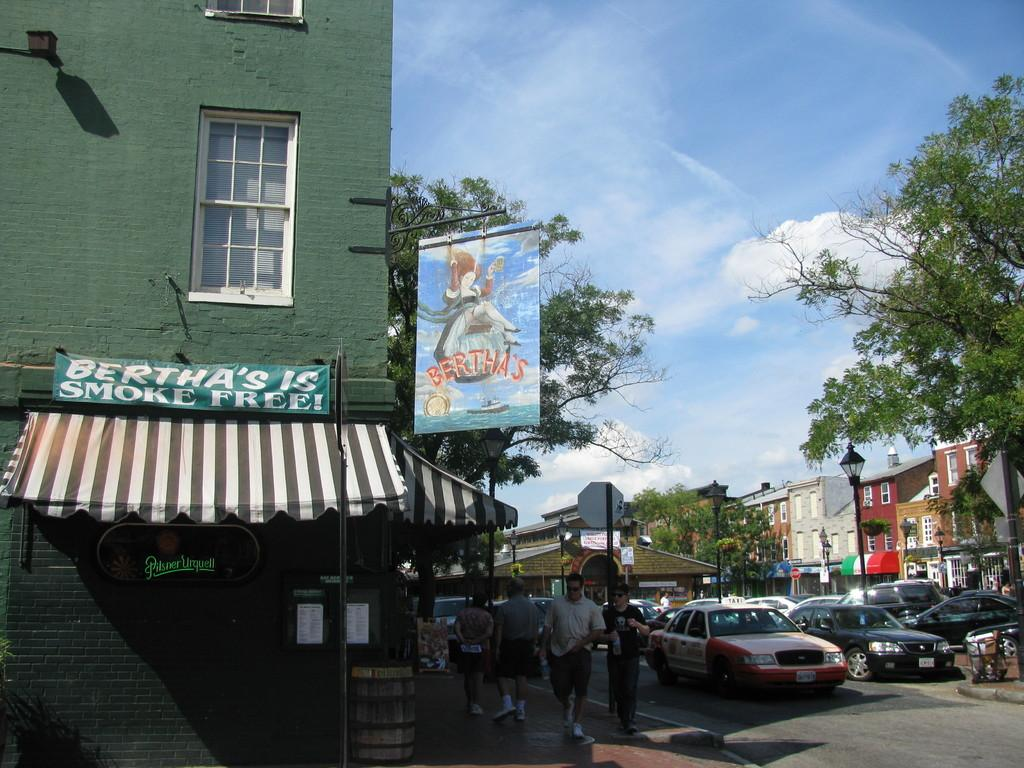<image>
Create a compact narrative representing the image presented. The sign for Bertha's depicts a woman on a swing. 